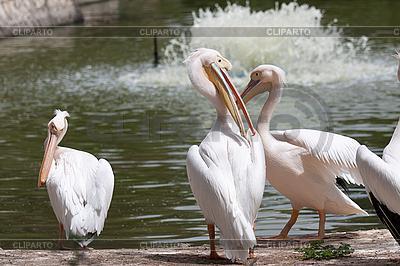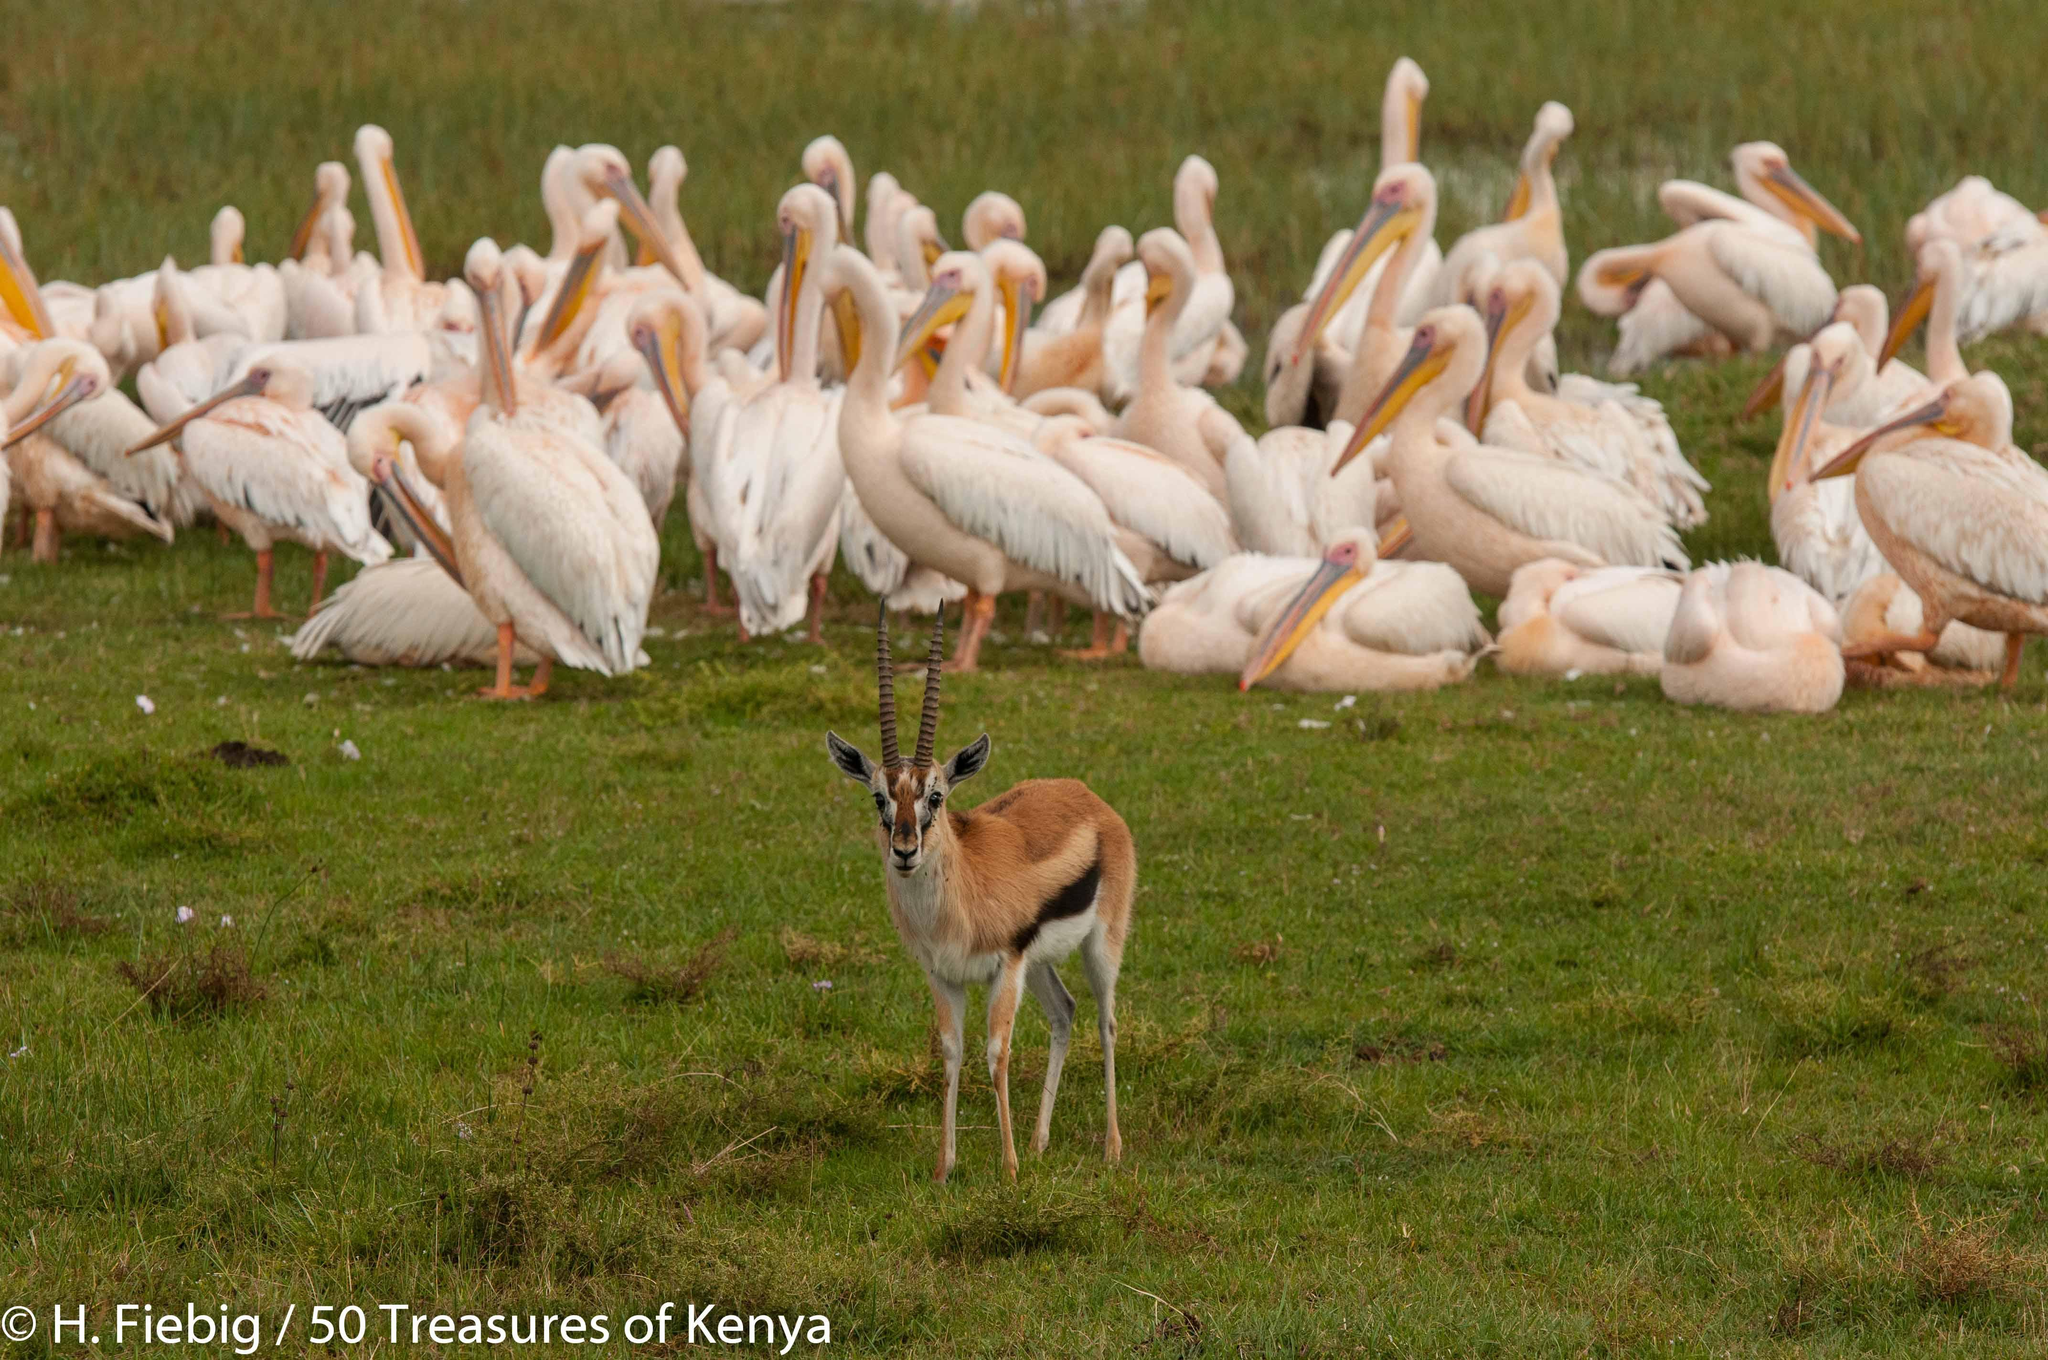The first image is the image on the left, the second image is the image on the right. Given the left and right images, does the statement "One of the images shows an animal with the birds." hold true? Answer yes or no. Yes. The first image is the image on the left, the second image is the image on the right. Assess this claim about the two images: "One of the images contain exactly 4 storks.". Correct or not? Answer yes or no. No. 